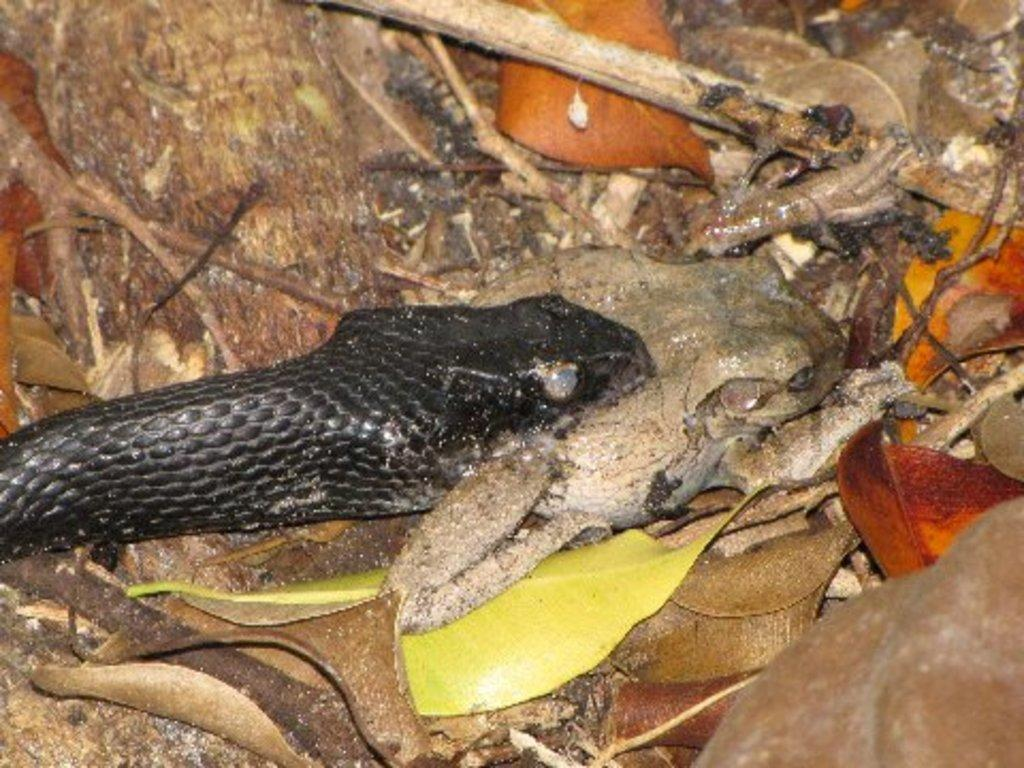What type of animal is in the image? There is a snake in the image. What type of vegetation is present in the image? There are leaves in the image. What other objects can be seen on the ground in the image? There are sticks in the image. Can you describe the objects on the ground in the image? There are objects on the ground in the image, but the specific nature of these objects is not mentioned in the provided facts. What type of silver beef is being served on a plate in the image? There is no silver beef or plate present in the image; it features a snake, leaves, and sticks. 